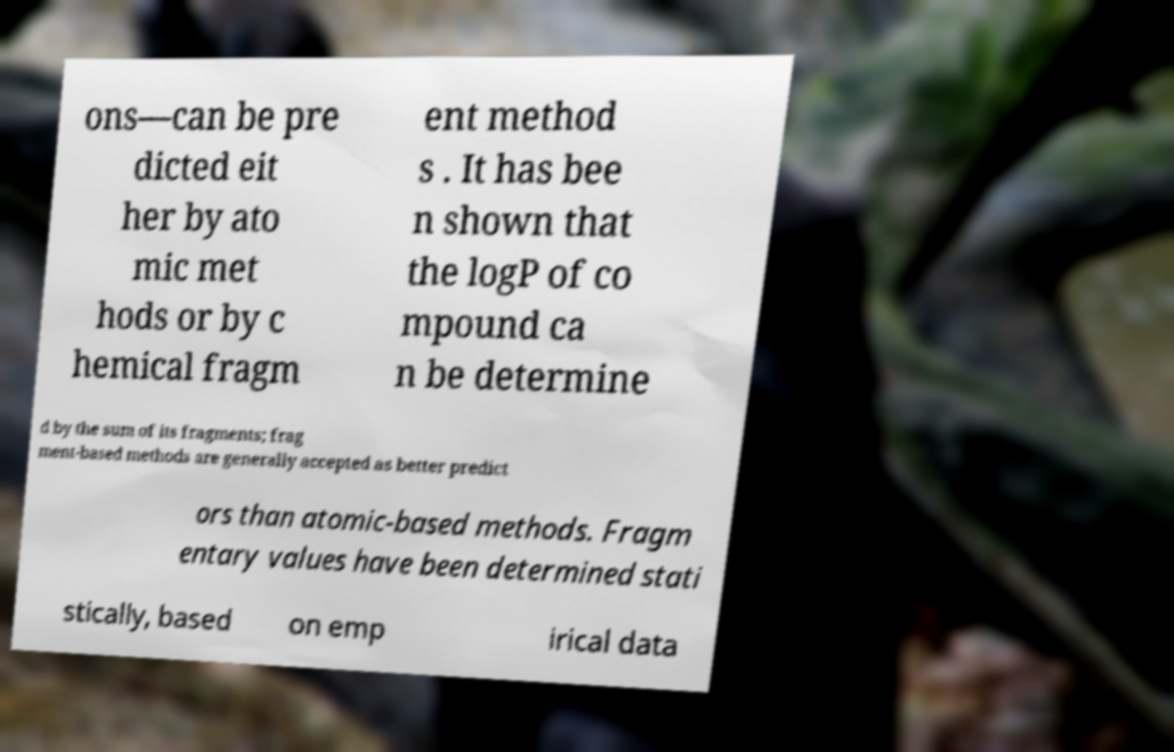Please identify and transcribe the text found in this image. ons—can be pre dicted eit her by ato mic met hods or by c hemical fragm ent method s . It has bee n shown that the logP of co mpound ca n be determine d by the sum of its fragments; frag ment-based methods are generally accepted as better predict ors than atomic-based methods. Fragm entary values have been determined stati stically, based on emp irical data 